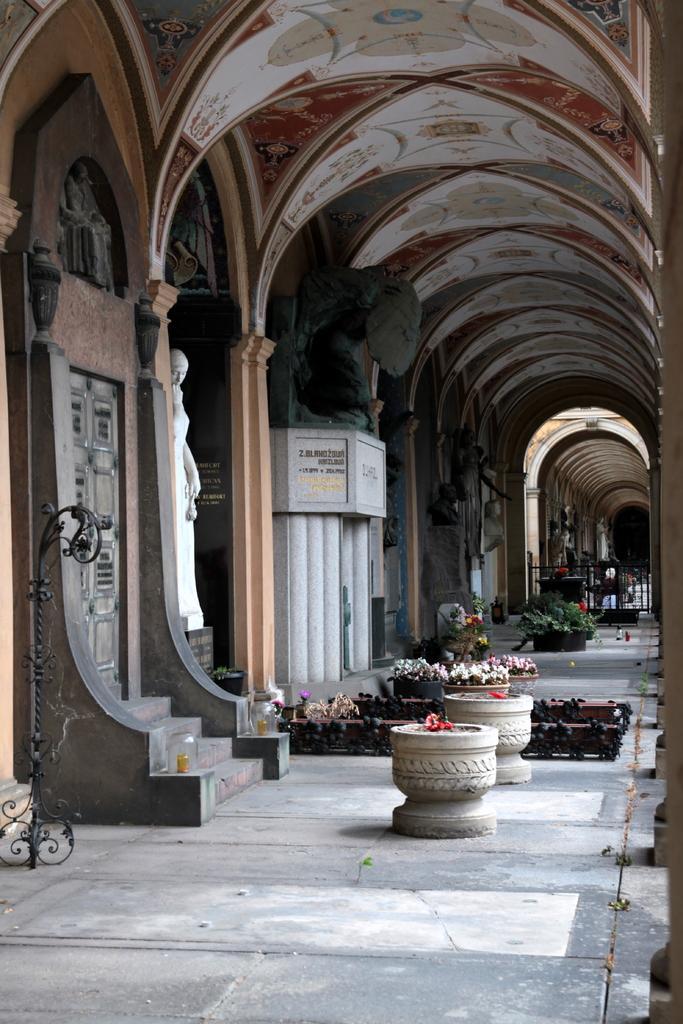How would you summarize this image in a sentence or two? In this image there are few pots having plants. Pots are kept on the floor. Left side there is a statue. Left side there is a stand. Background there is a wall having a door. Before the door there are stairs. Right side there is a fence. Few sculptures are on the wall. 